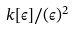Convert formula to latex. <formula><loc_0><loc_0><loc_500><loc_500>k [ \epsilon ] / ( \epsilon ) ^ { 2 }</formula> 